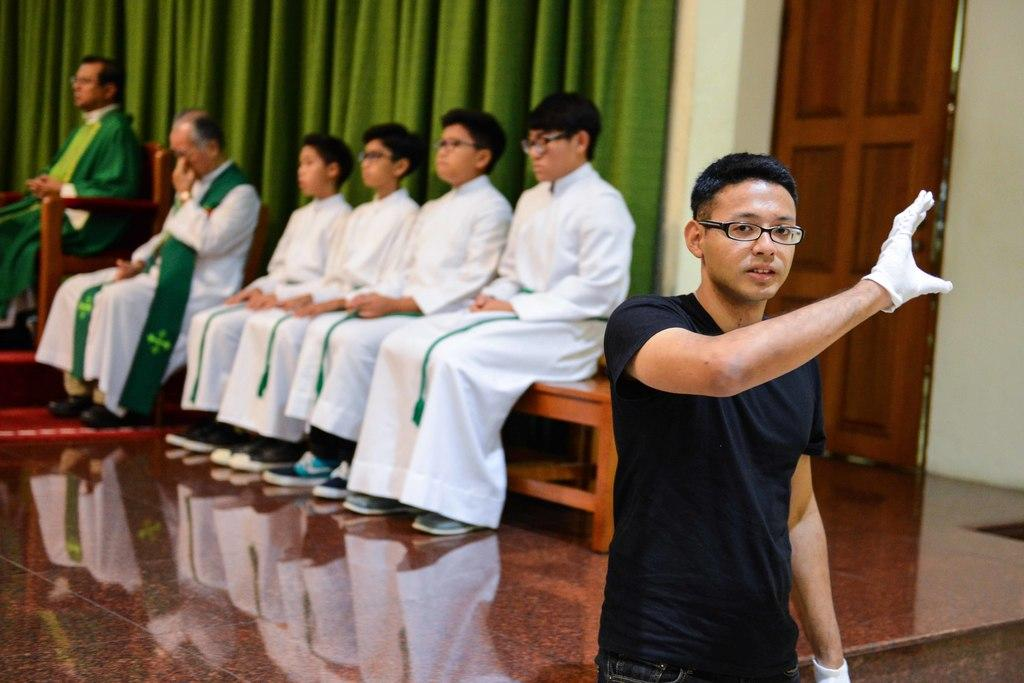What is the man in the image doing? The man is standing in the image. What are the people in the image doing? There are people sitting on chairs and on a bench in the image. What can be seen in the background of the image? There is a door and a curtain in the background of the image. What type of meat is being served at the event in the image? There is no event or meat present in the image. Can you see a donkey in the image? There is no donkey present in the image. 